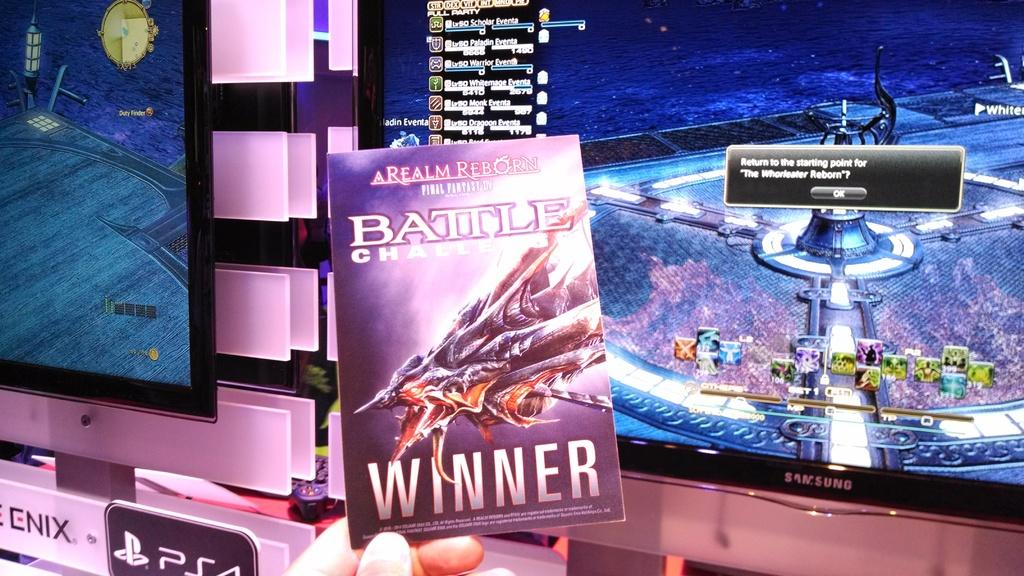<image>
Provide a brief description of the given image. Great reading of Battle Challe and video games is the way to spend down time. 